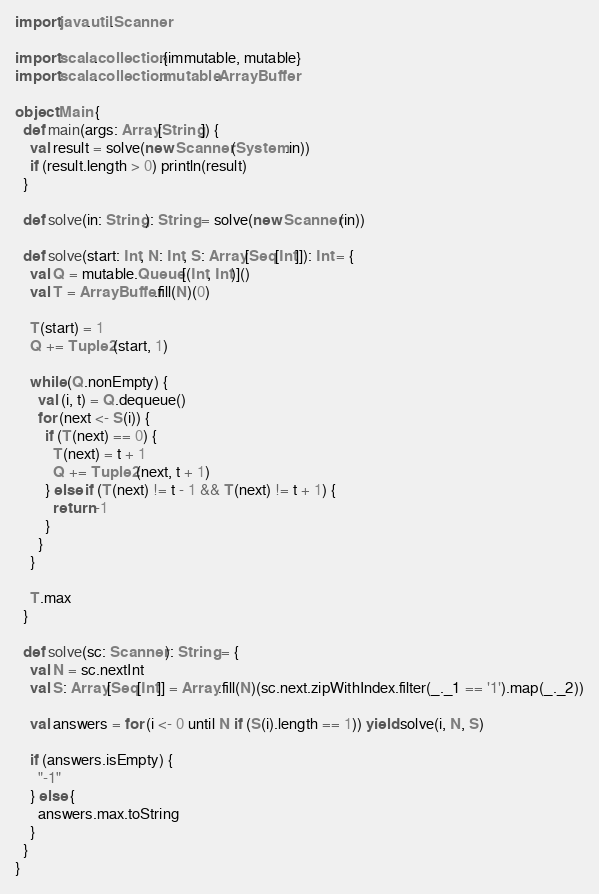<code> <loc_0><loc_0><loc_500><loc_500><_Scala_>import java.util.Scanner

import scala.collection.{immutable, mutable}
import scala.collection.mutable.ArrayBuffer

object Main {
  def main(args: Array[String]) {
    val result = solve(new Scanner(System.in))
    if (result.length > 0) println(result)
  }

  def solve(in: String): String = solve(new Scanner(in))

  def solve(start: Int, N: Int, S: Array[Seq[Int]]): Int = {
    val Q = mutable.Queue[(Int, Int)]()
    val T = ArrayBuffer.fill(N)(0)

    T(start) = 1
    Q += Tuple2(start, 1)

    while (Q.nonEmpty) {
      val (i, t) = Q.dequeue()
      for (next <- S(i)) {
        if (T(next) == 0) {
          T(next) = t + 1
          Q += Tuple2(next, t + 1)
        } else if (T(next) != t - 1 && T(next) != t + 1) {
          return -1
        }
      }
    }

    T.max
  }

  def solve(sc: Scanner): String = {
    val N = sc.nextInt
    val S: Array[Seq[Int]] = Array.fill(N)(sc.next.zipWithIndex.filter(_._1 == '1').map(_._2))

    val answers = for (i <- 0 until N if (S(i).length == 1)) yield solve(i, N, S)

    if (answers.isEmpty) {
      "-1"
    } else {
      answers.max.toString
    }
  }
}
</code> 